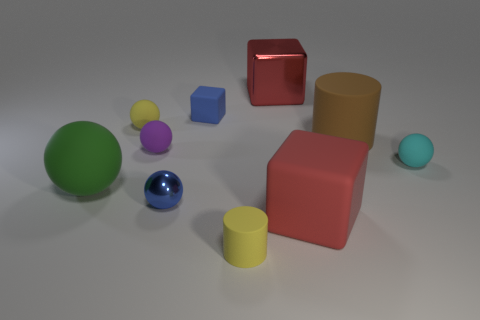Subtract all green balls. How many balls are left? 4 Subtract all gray cylinders. How many red blocks are left? 2 Subtract all yellow balls. How many balls are left? 4 Subtract 1 cylinders. How many cylinders are left? 1 Subtract all cylinders. How many objects are left? 8 Subtract all tiny blue cubes. Subtract all yellow cylinders. How many objects are left? 8 Add 4 small cylinders. How many small cylinders are left? 5 Add 2 large red objects. How many large red objects exist? 4 Subtract 0 yellow blocks. How many objects are left? 10 Subtract all yellow cylinders. Subtract all purple cubes. How many cylinders are left? 1 